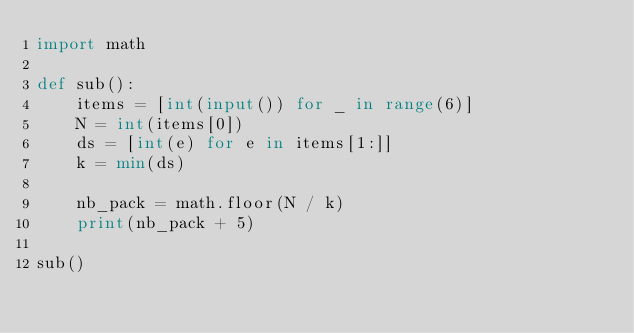<code> <loc_0><loc_0><loc_500><loc_500><_Python_>import math

def sub():
    items = [int(input()) for _ in range(6)]
    N = int(items[0])
    ds = [int(e) for e in items[1:]]
    k = min(ds)

    nb_pack = math.floor(N / k)
    print(nb_pack + 5)

sub()

</code> 